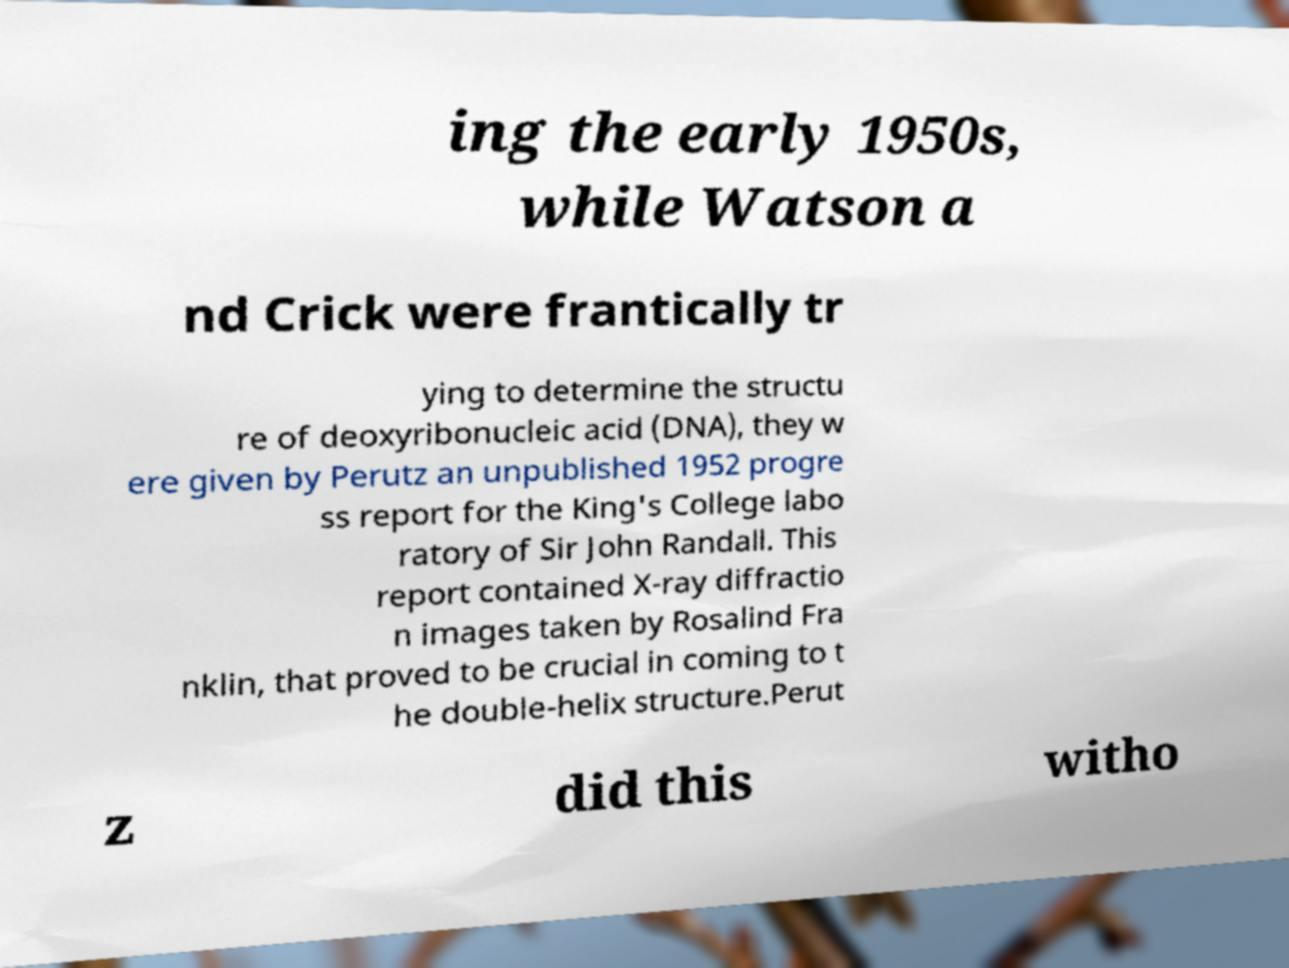Please identify and transcribe the text found in this image. ing the early 1950s, while Watson a nd Crick were frantically tr ying to determine the structu re of deoxyribonucleic acid (DNA), they w ere given by Perutz an unpublished 1952 progre ss report for the King's College labo ratory of Sir John Randall. This report contained X-ray diffractio n images taken by Rosalind Fra nklin, that proved to be crucial in coming to t he double-helix structure.Perut z did this witho 